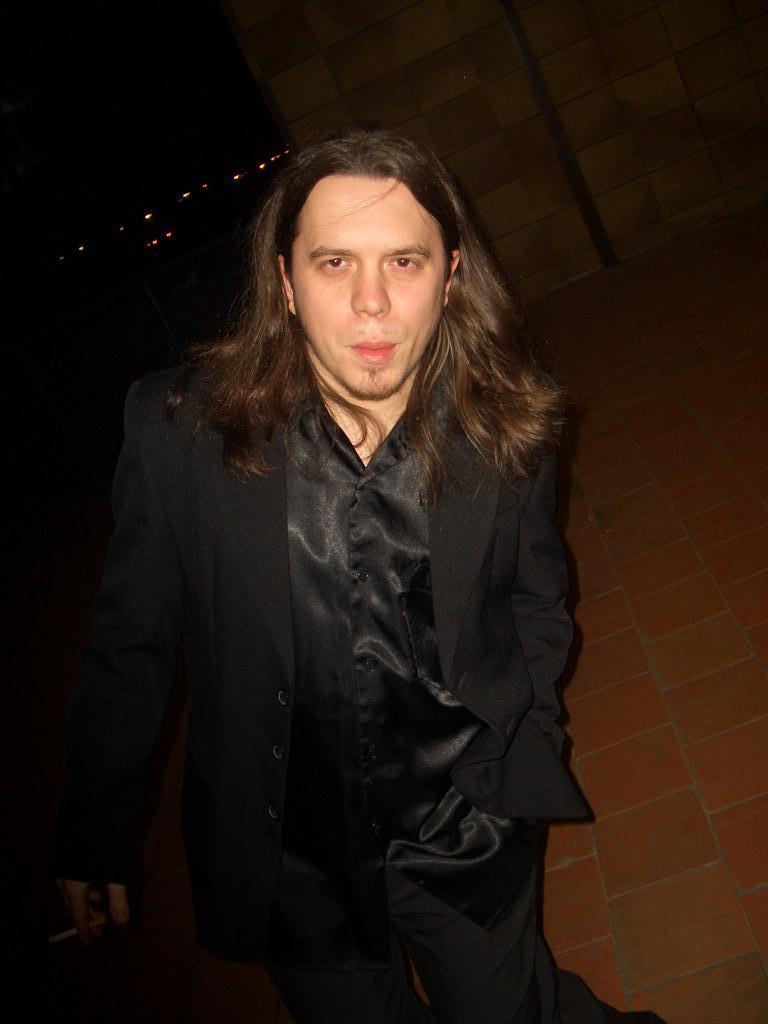What is the man in the image doing? The provided facts do not specify what the man is doing, only that he is standing. What is the man wearing in the image? The man is wearing a black suit in the image. What can be seen in the background of the image? There is a wall in the background of the image. What type of polish is the man applying to his shoes in the image? There is no indication in the image that the man is applying polish to his shoes, nor is there any mention of shoes in the provided facts. 